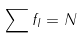Convert formula to latex. <formula><loc_0><loc_0><loc_500><loc_500>\sum f _ { I } = N</formula> 